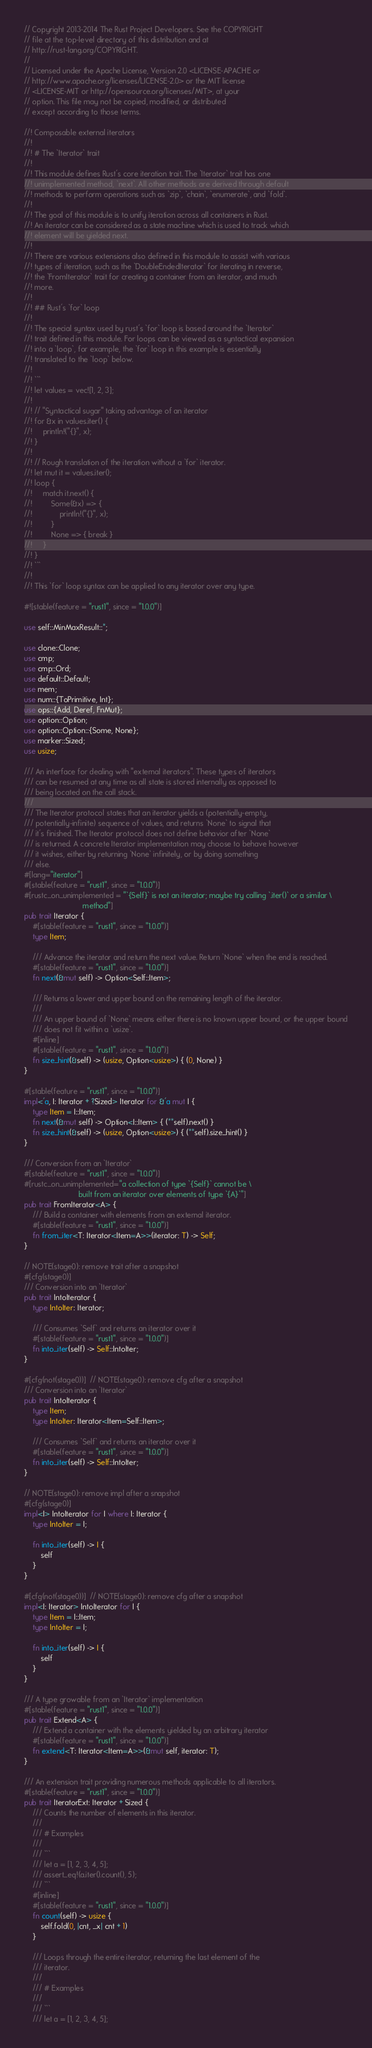Convert code to text. <code><loc_0><loc_0><loc_500><loc_500><_Rust_>// Copyright 2013-2014 The Rust Project Developers. See the COPYRIGHT
// file at the top-level directory of this distribution and at
// http://rust-lang.org/COPYRIGHT.
//
// Licensed under the Apache License, Version 2.0 <LICENSE-APACHE or
// http://www.apache.org/licenses/LICENSE-2.0> or the MIT license
// <LICENSE-MIT or http://opensource.org/licenses/MIT>, at your
// option. This file may not be copied, modified, or distributed
// except according to those terms.

//! Composable external iterators
//!
//! # The `Iterator` trait
//!
//! This module defines Rust's core iteration trait. The `Iterator` trait has one
//! unimplemented method, `next`. All other methods are derived through default
//! methods to perform operations such as `zip`, `chain`, `enumerate`, and `fold`.
//!
//! The goal of this module is to unify iteration across all containers in Rust.
//! An iterator can be considered as a state machine which is used to track which
//! element will be yielded next.
//!
//! There are various extensions also defined in this module to assist with various
//! types of iteration, such as the `DoubleEndedIterator` for iterating in reverse,
//! the `FromIterator` trait for creating a container from an iterator, and much
//! more.
//!
//! ## Rust's `for` loop
//!
//! The special syntax used by rust's `for` loop is based around the `Iterator`
//! trait defined in this module. For loops can be viewed as a syntactical expansion
//! into a `loop`, for example, the `for` loop in this example is essentially
//! translated to the `loop` below.
//!
//! ```
//! let values = vec![1, 2, 3];
//!
//! // "Syntactical sugar" taking advantage of an iterator
//! for &x in values.iter() {
//!     println!("{}", x);
//! }
//!
//! // Rough translation of the iteration without a `for` iterator.
//! let mut it = values.iter();
//! loop {
//!     match it.next() {
//!         Some(&x) => {
//!             println!("{}", x);
//!         }
//!         None => { break }
//!     }
//! }
//! ```
//!
//! This `for` loop syntax can be applied to any iterator over any type.

#![stable(feature = "rust1", since = "1.0.0")]

use self::MinMaxResult::*;

use clone::Clone;
use cmp;
use cmp::Ord;
use default::Default;
use mem;
use num::{ToPrimitive, Int};
use ops::{Add, Deref, FnMut};
use option::Option;
use option::Option::{Some, None};
use marker::Sized;
use usize;

/// An interface for dealing with "external iterators". These types of iterators
/// can be resumed at any time as all state is stored internally as opposed to
/// being located on the call stack.
///
/// The Iterator protocol states that an iterator yields a (potentially-empty,
/// potentially-infinite) sequence of values, and returns `None` to signal that
/// it's finished. The Iterator protocol does not define behavior after `None`
/// is returned. A concrete Iterator implementation may choose to behave however
/// it wishes, either by returning `None` infinitely, or by doing something
/// else.
#[lang="iterator"]
#[stable(feature = "rust1", since = "1.0.0")]
#[rustc_on_unimplemented = "`{Self}` is not an iterator; maybe try calling `.iter()` or a similar \
                            method"]
pub trait Iterator {
    #[stable(feature = "rust1", since = "1.0.0")]
    type Item;

    /// Advance the iterator and return the next value. Return `None` when the end is reached.
    #[stable(feature = "rust1", since = "1.0.0")]
    fn next(&mut self) -> Option<Self::Item>;

    /// Returns a lower and upper bound on the remaining length of the iterator.
    ///
    /// An upper bound of `None` means either there is no known upper bound, or the upper bound
    /// does not fit within a `usize`.
    #[inline]
    #[stable(feature = "rust1", since = "1.0.0")]
    fn size_hint(&self) -> (usize, Option<usize>) { (0, None) }
}

#[stable(feature = "rust1", since = "1.0.0")]
impl<'a, I: Iterator + ?Sized> Iterator for &'a mut I {
    type Item = I::Item;
    fn next(&mut self) -> Option<I::Item> { (**self).next() }
    fn size_hint(&self) -> (usize, Option<usize>) { (**self).size_hint() }
}

/// Conversion from an `Iterator`
#[stable(feature = "rust1", since = "1.0.0")]
#[rustc_on_unimplemented="a collection of type `{Self}` cannot be \
                          built from an iterator over elements of type `{A}`"]
pub trait FromIterator<A> {
    /// Build a container with elements from an external iterator.
    #[stable(feature = "rust1", since = "1.0.0")]
    fn from_iter<T: Iterator<Item=A>>(iterator: T) -> Self;
}

// NOTE(stage0): remove trait after a snapshot
#[cfg(stage0)]
/// Conversion into an `Iterator`
pub trait IntoIterator {
    type IntoIter: Iterator;

    /// Consumes `Self` and returns an iterator over it
    #[stable(feature = "rust1", since = "1.0.0")]
    fn into_iter(self) -> Self::IntoIter;
}

#[cfg(not(stage0))]  // NOTE(stage0): remove cfg after a snapshot
/// Conversion into an `Iterator`
pub trait IntoIterator {
    type Item;
    type IntoIter: Iterator<Item=Self::Item>;

    /// Consumes `Self` and returns an iterator over it
    #[stable(feature = "rust1", since = "1.0.0")]
    fn into_iter(self) -> Self::IntoIter;
}

// NOTE(stage0): remove impl after a snapshot
#[cfg(stage0)]
impl<I> IntoIterator for I where I: Iterator {
    type IntoIter = I;

    fn into_iter(self) -> I {
        self
    }
}

#[cfg(not(stage0))]  // NOTE(stage0): remove cfg after a snapshot
impl<I: Iterator> IntoIterator for I {
    type Item = I::Item;
    type IntoIter = I;

    fn into_iter(self) -> I {
        self
    }
}

/// A type growable from an `Iterator` implementation
#[stable(feature = "rust1", since = "1.0.0")]
pub trait Extend<A> {
    /// Extend a container with the elements yielded by an arbitrary iterator
    #[stable(feature = "rust1", since = "1.0.0")]
    fn extend<T: Iterator<Item=A>>(&mut self, iterator: T);
}

/// An extension trait providing numerous methods applicable to all iterators.
#[stable(feature = "rust1", since = "1.0.0")]
pub trait IteratorExt: Iterator + Sized {
    /// Counts the number of elements in this iterator.
    ///
    /// # Examples
    ///
    /// ```
    /// let a = [1, 2, 3, 4, 5];
    /// assert_eq!(a.iter().count(), 5);
    /// ```
    #[inline]
    #[stable(feature = "rust1", since = "1.0.0")]
    fn count(self) -> usize {
        self.fold(0, |cnt, _x| cnt + 1)
    }

    /// Loops through the entire iterator, returning the last element of the
    /// iterator.
    ///
    /// # Examples
    ///
    /// ```
    /// let a = [1, 2, 3, 4, 5];</code> 